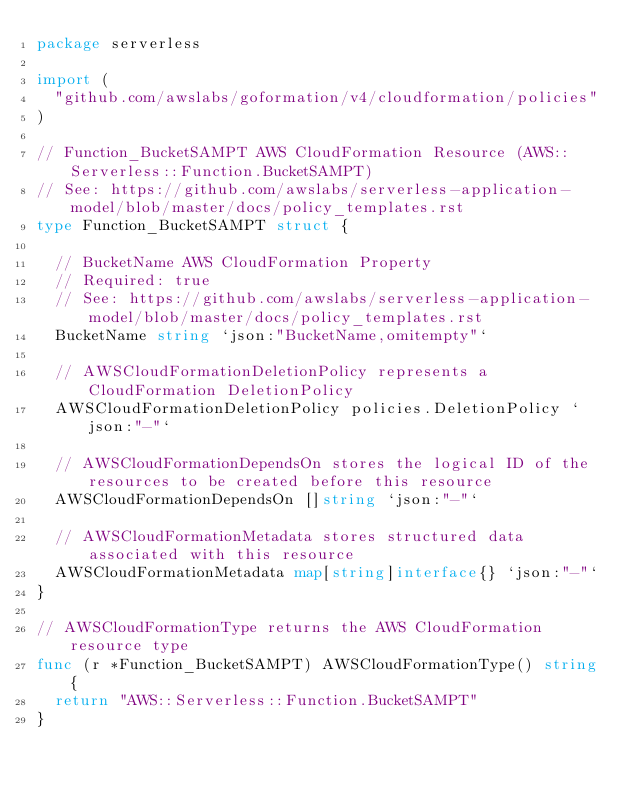<code> <loc_0><loc_0><loc_500><loc_500><_Go_>package serverless

import (
	"github.com/awslabs/goformation/v4/cloudformation/policies"
)

// Function_BucketSAMPT AWS CloudFormation Resource (AWS::Serverless::Function.BucketSAMPT)
// See: https://github.com/awslabs/serverless-application-model/blob/master/docs/policy_templates.rst
type Function_BucketSAMPT struct {

	// BucketName AWS CloudFormation Property
	// Required: true
	// See: https://github.com/awslabs/serverless-application-model/blob/master/docs/policy_templates.rst
	BucketName string `json:"BucketName,omitempty"`

	// AWSCloudFormationDeletionPolicy represents a CloudFormation DeletionPolicy
	AWSCloudFormationDeletionPolicy policies.DeletionPolicy `json:"-"`

	// AWSCloudFormationDependsOn stores the logical ID of the resources to be created before this resource
	AWSCloudFormationDependsOn []string `json:"-"`

	// AWSCloudFormationMetadata stores structured data associated with this resource
	AWSCloudFormationMetadata map[string]interface{} `json:"-"`
}

// AWSCloudFormationType returns the AWS CloudFormation resource type
func (r *Function_BucketSAMPT) AWSCloudFormationType() string {
	return "AWS::Serverless::Function.BucketSAMPT"
}
</code> 